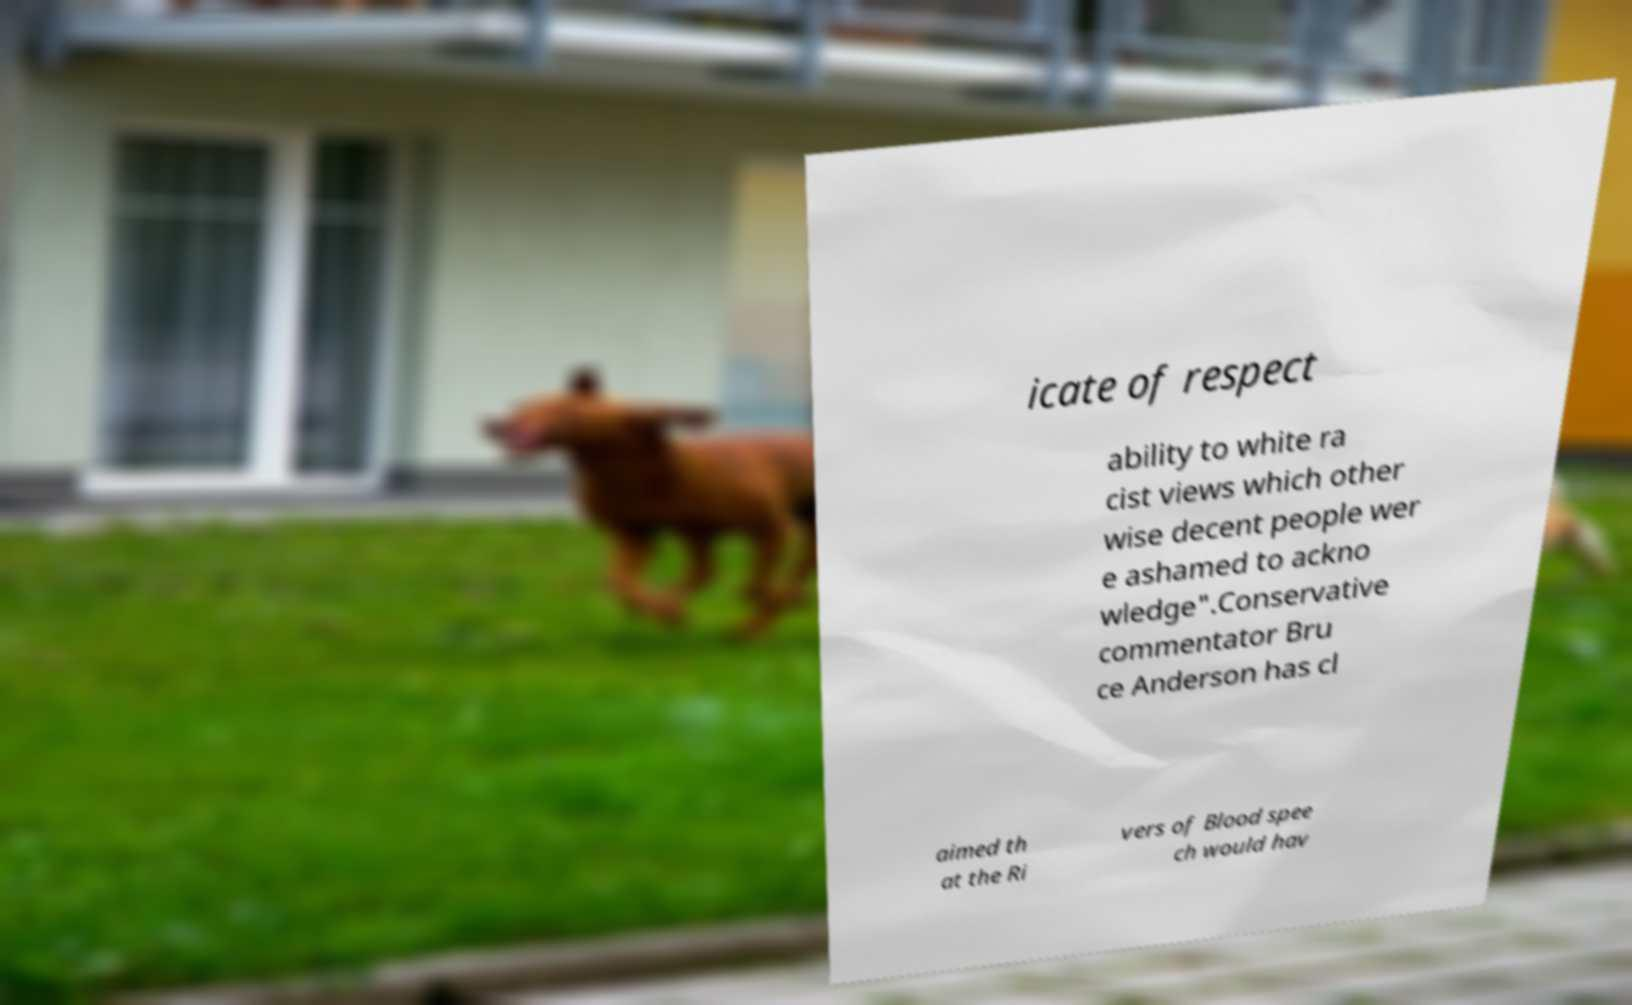Can you accurately transcribe the text from the provided image for me? icate of respect ability to white ra cist views which other wise decent people wer e ashamed to ackno wledge".Conservative commentator Bru ce Anderson has cl aimed th at the Ri vers of Blood spee ch would hav 